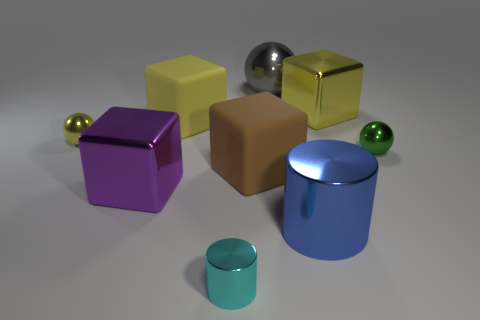Subtract all blocks. How many objects are left? 5 Add 5 tiny green metal things. How many tiny green metal things exist? 6 Subtract 0 brown cylinders. How many objects are left? 9 Subtract all green objects. Subtract all metal things. How many objects are left? 1 Add 4 big brown objects. How many big brown objects are left? 5 